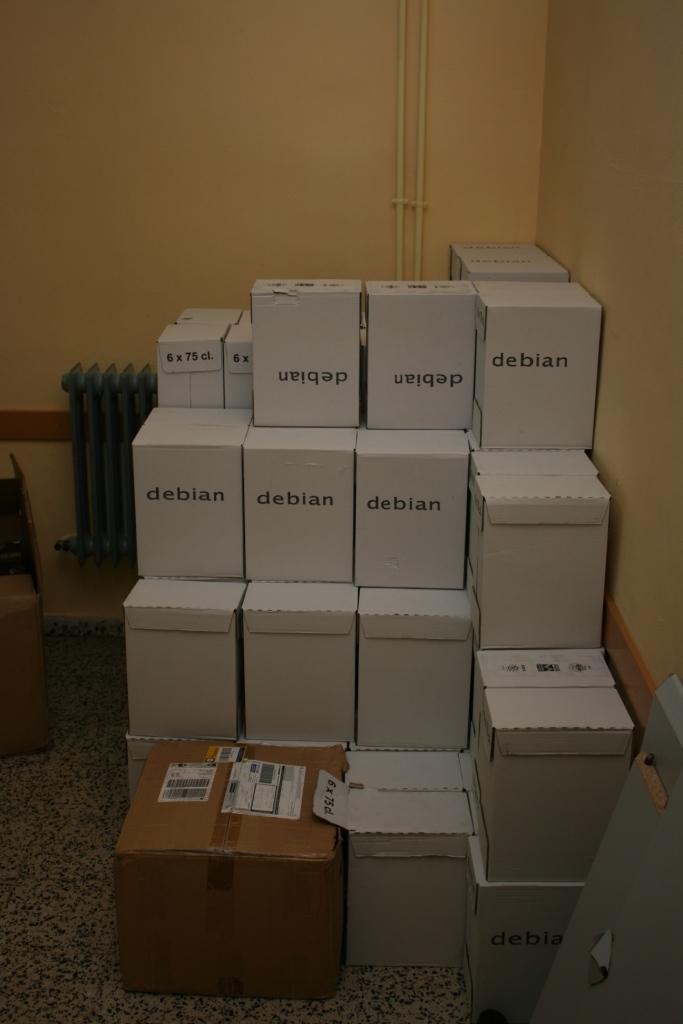<image>
Write a terse but informative summary of the picture. Boxes with the word debian are stacked on top of each other. 